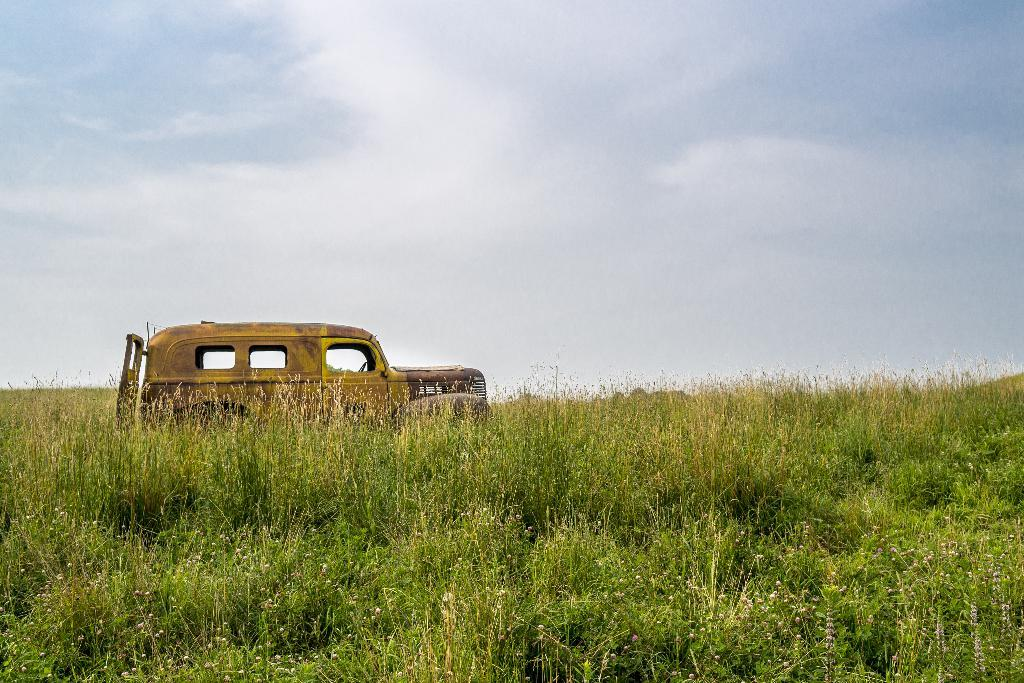What is parked on the ground in the image? There is a vehicle parked on the ground in the image. What else can be seen on the ground in the image? There are plants on the ground in the image. What is the condition of the sky in the image? The sky is clear in the image. Can you tell me how many horses are visible in the image? There are no horses present in the image. What type of process is being carried out in the alley in the image? There is no alley or any process being carried out in the image. 